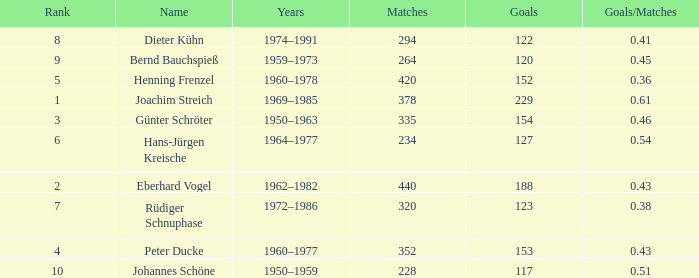What average goals have matches less than 228? None. 